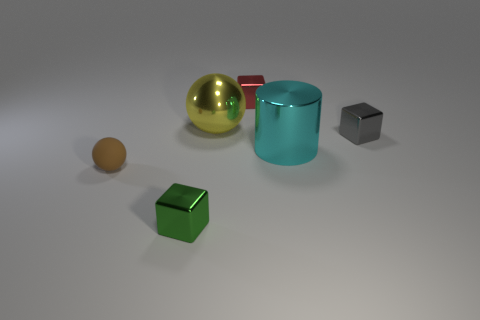Add 2 tiny spheres. How many objects exist? 8 Subtract all cylinders. How many objects are left? 5 Add 6 tiny brown matte objects. How many tiny brown matte objects are left? 7 Add 4 metallic balls. How many metallic balls exist? 5 Subtract 0 gray cylinders. How many objects are left? 6 Subtract all small gray shiny cubes. Subtract all matte objects. How many objects are left? 4 